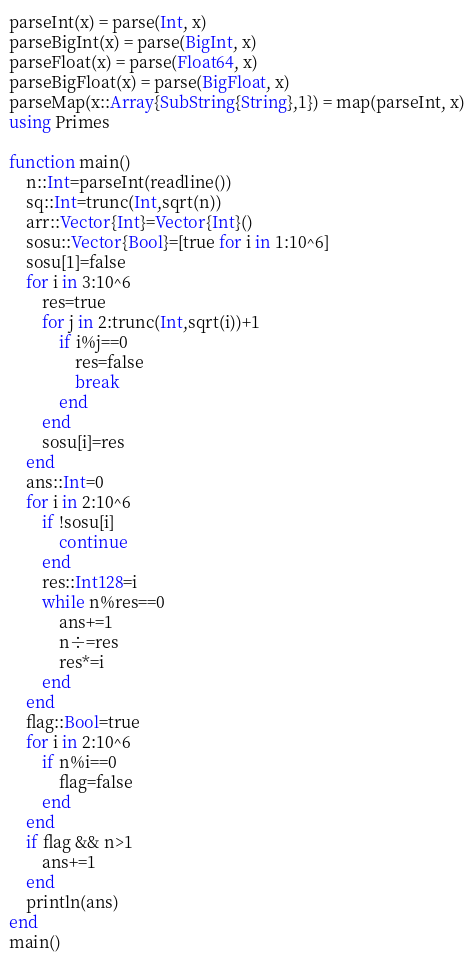Convert code to text. <code><loc_0><loc_0><loc_500><loc_500><_Julia_>parseInt(x) = parse(Int, x)
parseBigInt(x) = parse(BigInt, x)
parseFloat(x) = parse(Float64, x)
parseBigFloat(x) = parse(BigFloat, x)
parseMap(x::Array{SubString{String},1}) = map(parseInt, x)
using Primes

function main()
    n::Int=parseInt(readline())
    sq::Int=trunc(Int,sqrt(n))
    arr::Vector{Int}=Vector{Int}()
    sosu::Vector{Bool}=[true for i in 1:10^6]
    sosu[1]=false
    for i in 3:10^6
        res=true
        for j in 2:trunc(Int,sqrt(i))+1
            if i%j==0
                res=false
                break
            end
        end
        sosu[i]=res
    end
    ans::Int=0
    for i in 2:10^6
        if !sosu[i]
            continue
        end
        res::Int128=i
        while n%res==0
            ans+=1
            n÷=res
            res*=i
        end
    end
    flag::Bool=true
    for i in 2:10^6
        if n%i==0
            flag=false
        end
    end
    if flag && n>1
        ans+=1
    end
    println(ans)
end
main()</code> 